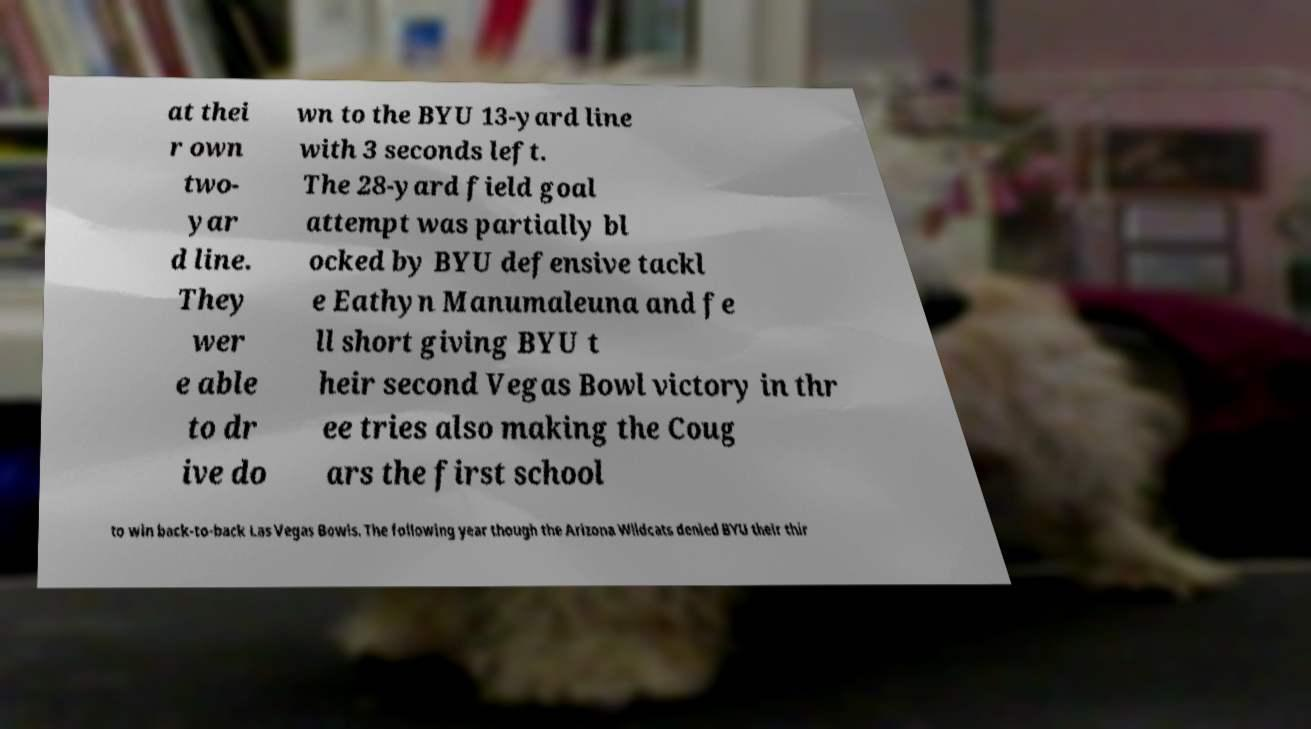Please read and relay the text visible in this image. What does it say? at thei r own two- yar d line. They wer e able to dr ive do wn to the BYU 13-yard line with 3 seconds left. The 28-yard field goal attempt was partially bl ocked by BYU defensive tackl e Eathyn Manumaleuna and fe ll short giving BYU t heir second Vegas Bowl victory in thr ee tries also making the Coug ars the first school to win back-to-back Las Vegas Bowls. The following year though the Arizona Wildcats denied BYU their thir 